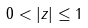Convert formula to latex. <formula><loc_0><loc_0><loc_500><loc_500>0 < | z | \leq 1</formula> 